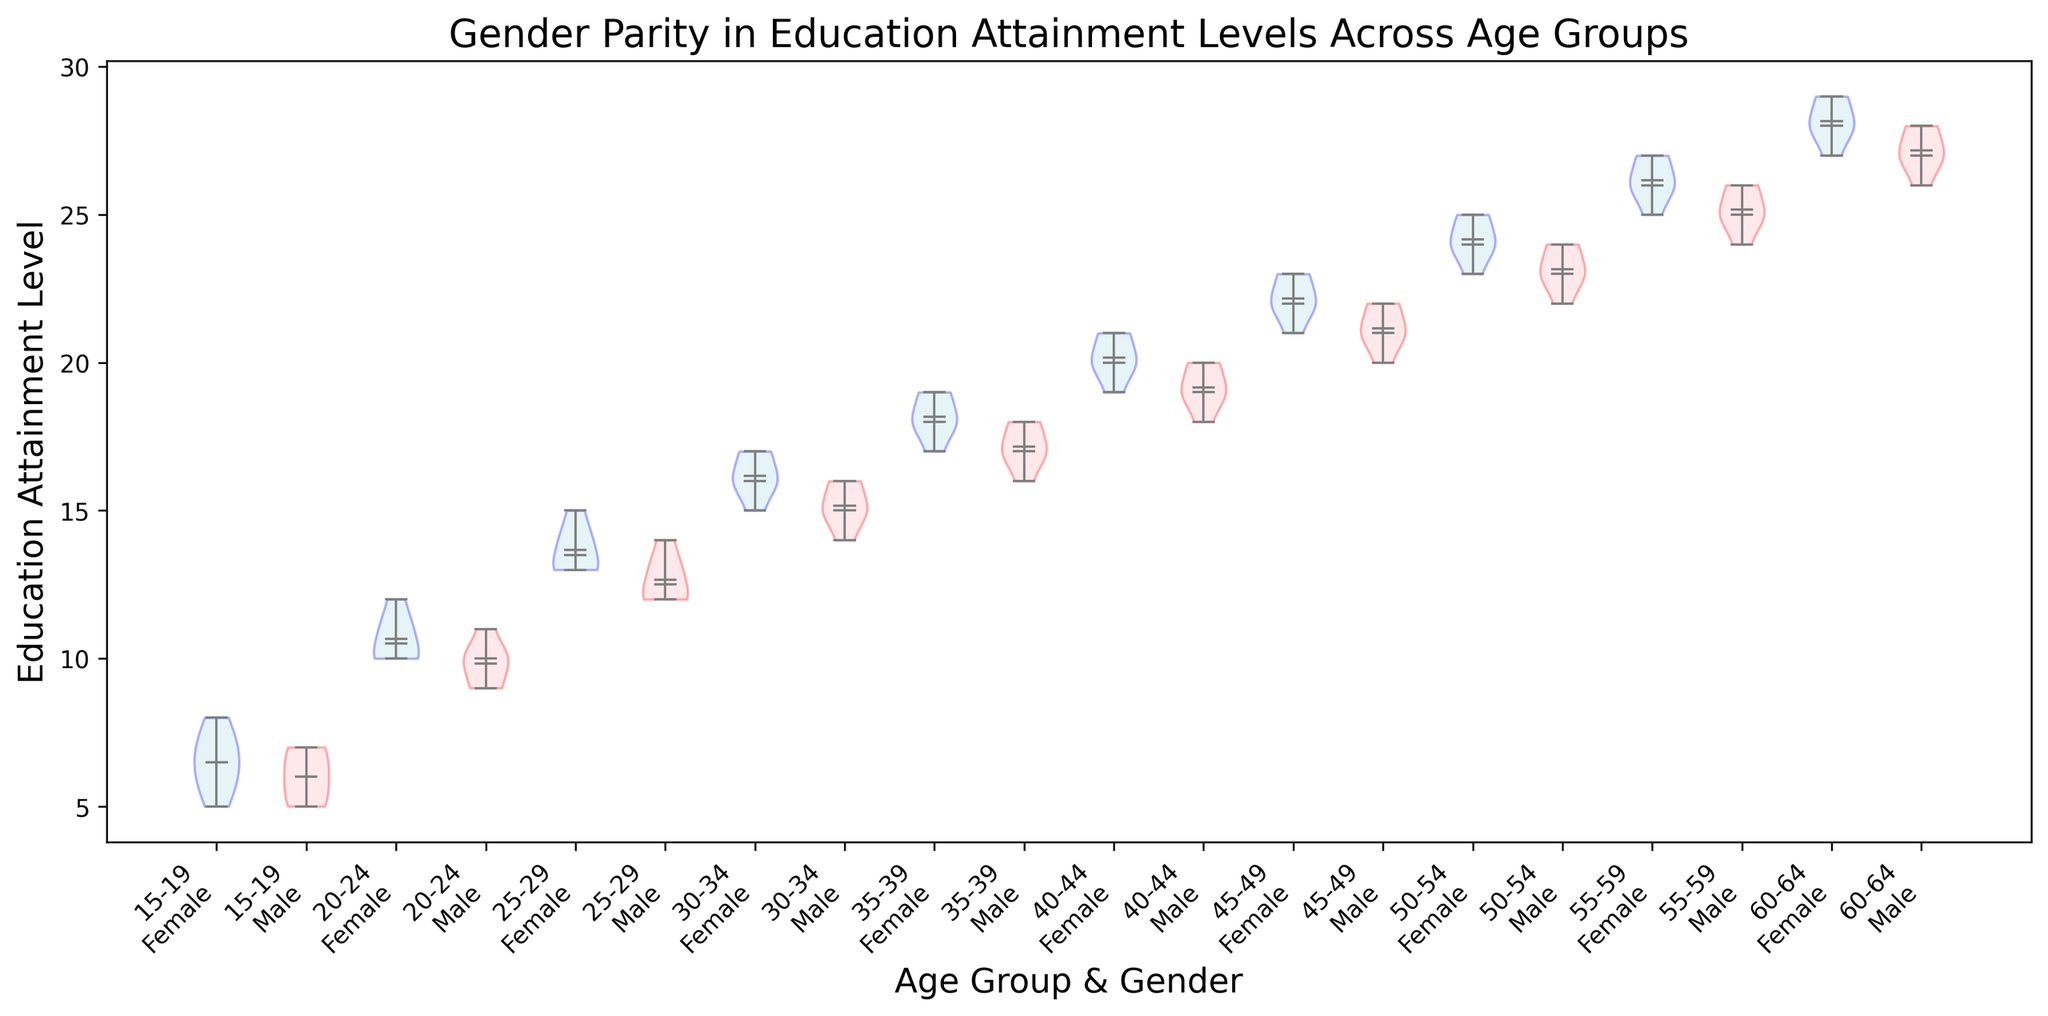Which age group has the median education attainment level highest for females? The median education attainment level for each age group can be observed from the horizontal line inside the violin plot for females. By comparing these lines across all age groups, it is clear that the 60-64 age group has the highest education attainment level for females, with a median around 28.
Answer: 60-64 Which age group shows the closest median education attainment levels between males and females? To determine this, compare the median lines for males and females within each age group. The violin plots for the age groups 25-29 and 50-54 both show very close median levels between males and females.
Answer: 25-29, 50-54 What is the difference between the highest and lowest median education attainment levels across all groups? First identify the highest and lowest median levels by examining the horizontal median lines within the plots. The highest median is 28 (60-64 females) and the lowest median is 5.5 (15-19 females). The difference is 28 - 5.5.
Answer: 22.5 Which gender generally has a higher mean education attainment level in the 30-34 age group? Identify the mean markers (small dots) within the 30-34 age group's violin plots. The mean mark for females is slightly higher than for males.
Answer: Female What color are the violin plots for males? The violin plots for males use light pink for the filled area.
Answer: Light pink Which age group has the widest range of education attainment levels for females? The range can be determined by looking at the span of the violin plots. The 45-49 age group females have the widest span, as their plot ranges from 21 to 23.
Answer: 45-49 Does any age group show males and females having non-overlapping education attainment levels? Non-overlapping distributions are observed in the plots where the male and female distributions do not intersect. For the 45-49 and 55-59 age groups, there are no overlaps between males and females.
Answer: 45-49, 55-59 Which age group has the smallest interquartile range (IQR) for males? The IQR is represented by the width of the violin plot around the median. The 40-44 age group's male violin plot shows the smallest interquartile range.
Answer: 40-44 